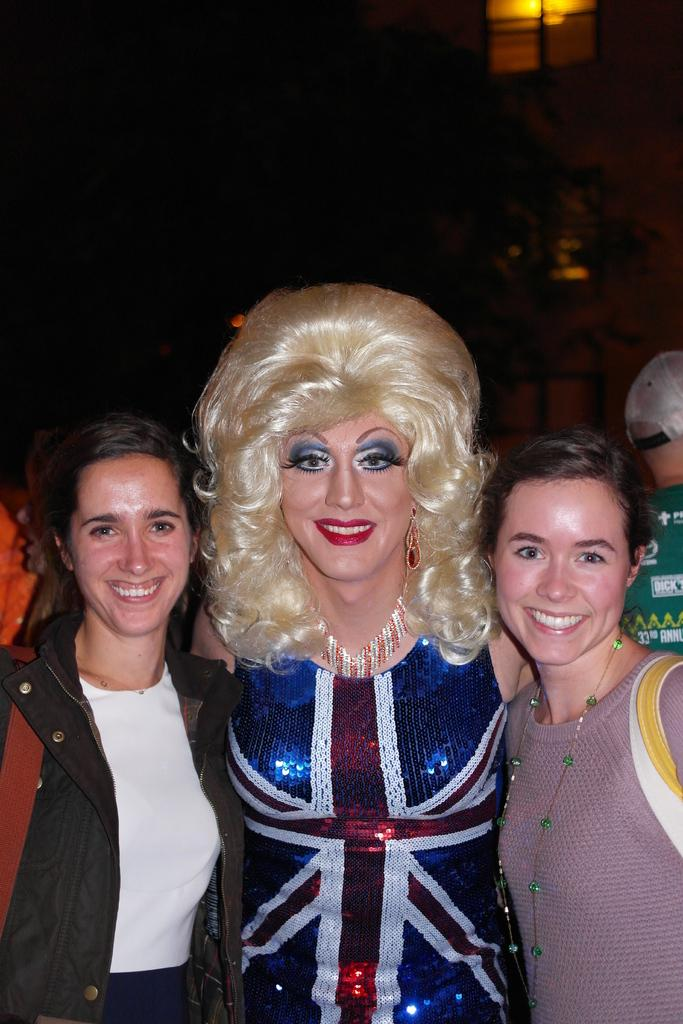What is happening in the image? There are women standing in the image, and they are smiling. What can be seen in the background of the image? There are windows and persons visible in the background of the image. What type of kitten is being held by one of the women in the image? There is no kitten present in the image; only the women and the background can be observed. What type of party is the group attending in the image? There is no indication of a party or any specific event in the image. 